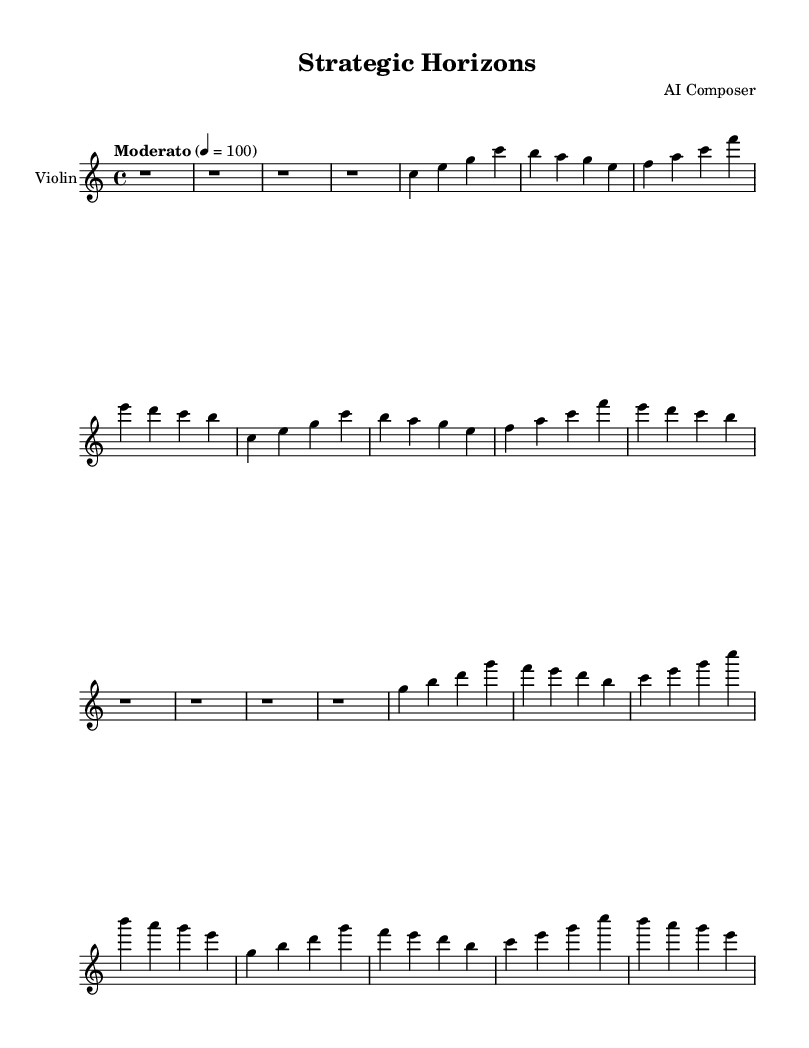What is the key signature of this music? The key signature indicates that the music is composed in C major, which has no sharps or flats.
Answer: C major What is the time signature of this piece? The time signature is represented by the fraction face of 4/4, meaning there are four beats in each measure, with the quarter note receiving one beat.
Answer: 4/4 What is the tempo marking of the composition? The tempo marking is a Moderate speed set to 100 beats per minute.
Answer: Moderato 4 = 100 How many measures are in the introduction section? The introduction section consists of four measures, represented by four rests, noted by the four "r1" symbols in succession.
Answer: 4 What musical themes are present in this piece? The piece includes two distinct musical themes: Main Theme A and Main Theme B, indicated by labels in the structure of the music.
Answer: Main Theme A and Main Theme B Which instrument is this score written for? The score is explicitly written for the Violin, as indicated in the staff name and the provided instrument definition.
Answer: Violin What notes make up the opening of Main Theme A? The opening notes of Main Theme A are C, E, G, and C, represented by the first set of notes after the rests.
Answer: C, E, G, C 